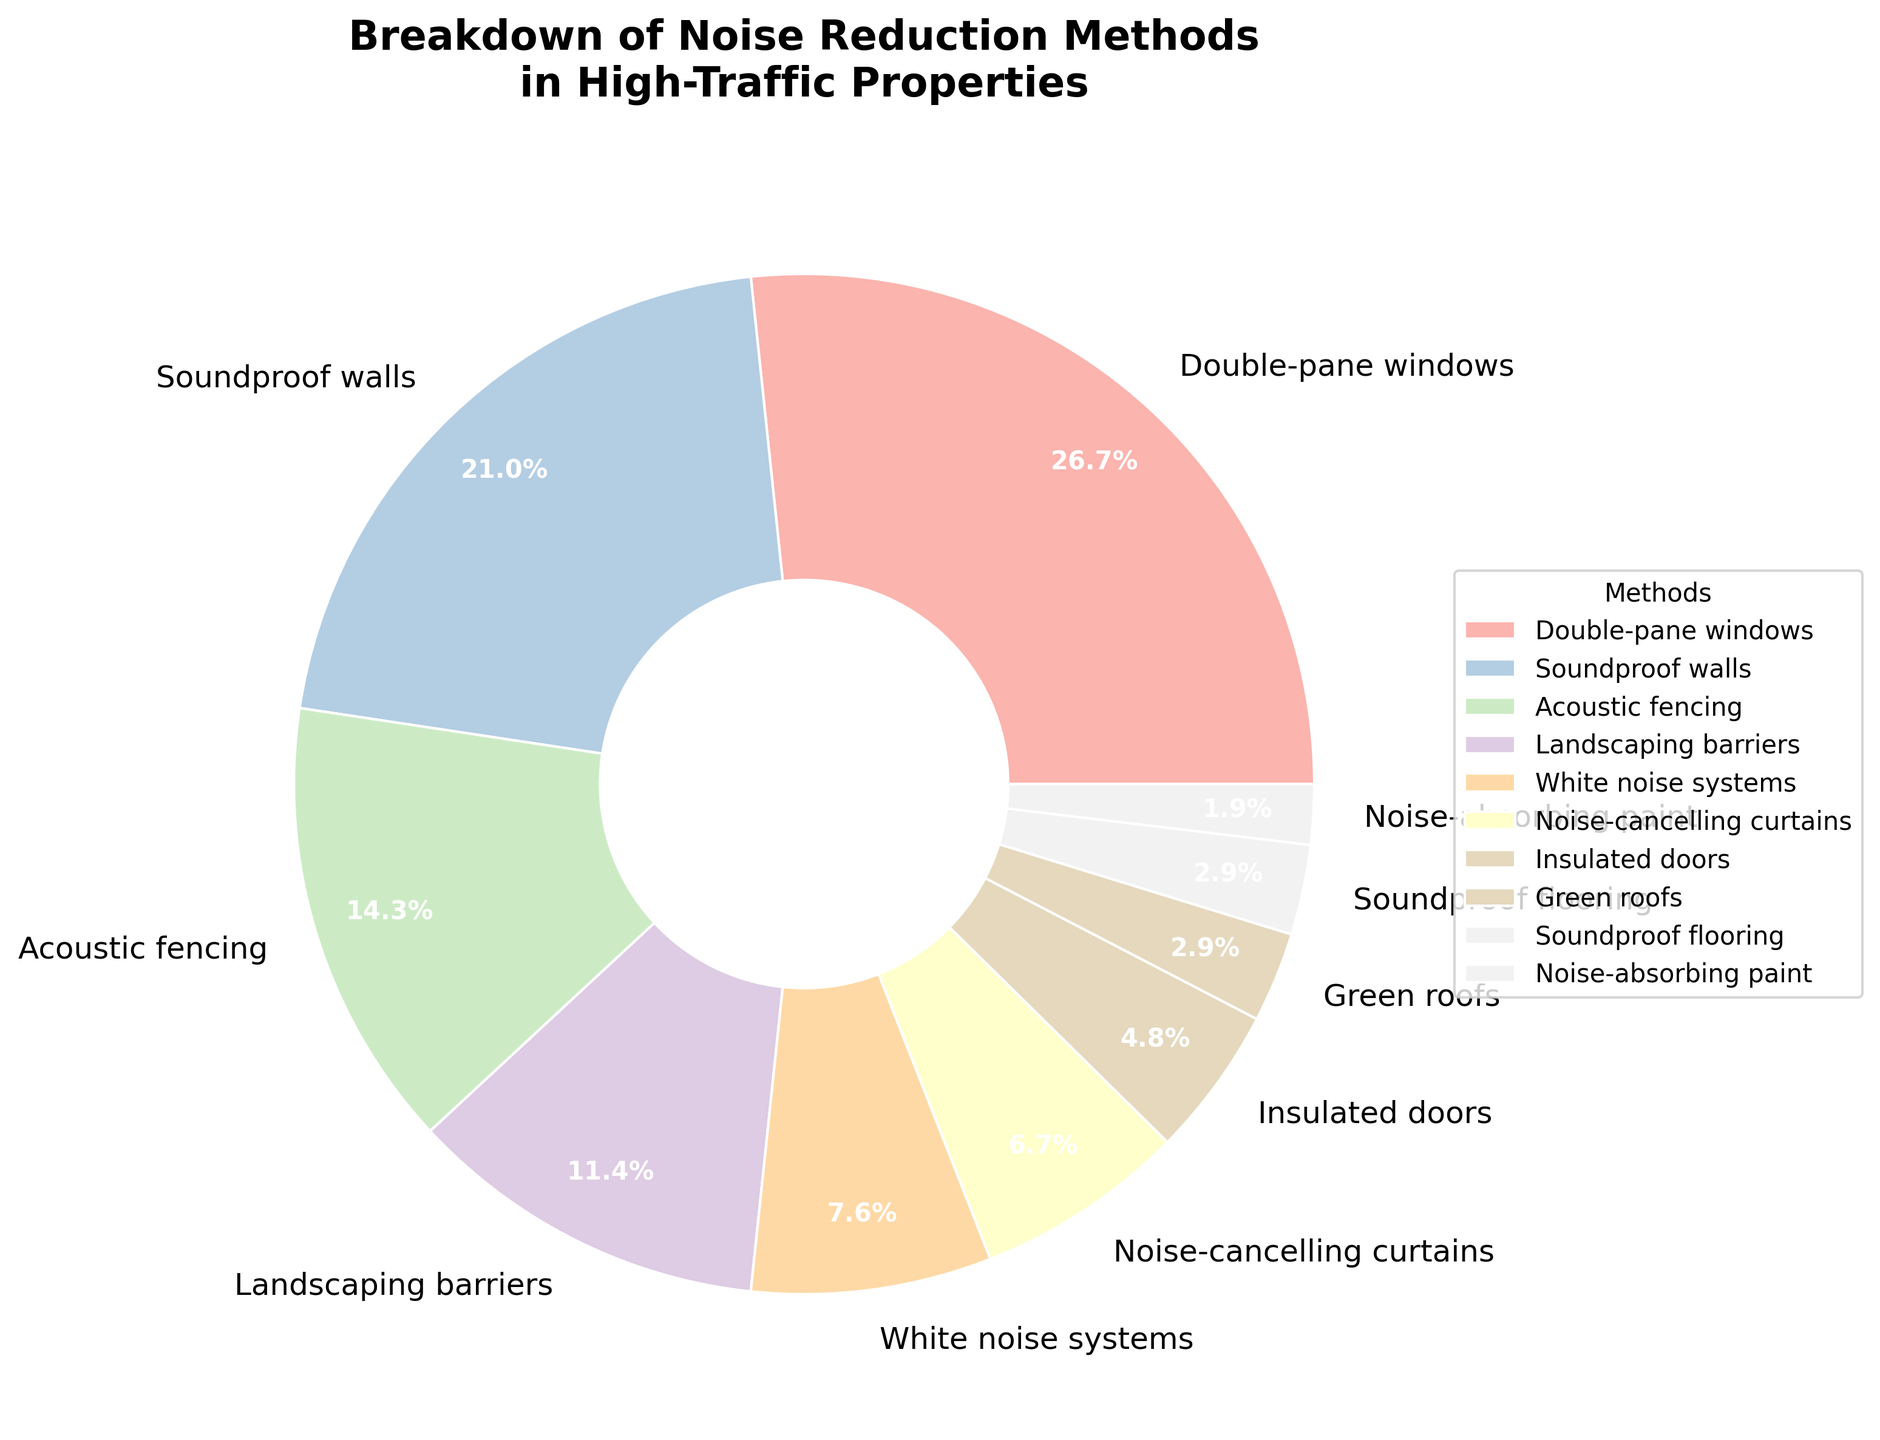What is the most common noise reduction method used in high-traffic properties? The most common noise reduction method is the one with the highest percentage in the pie chart. Double-pane windows have the largest section in the pie chart at 28%.
Answer: Double-pane windows Which noise reduction method is the least common? The least common method is the one with the smallest percentage in the pie chart. Noise-absorbing paint has the smallest section at 2%.
Answer: Noise-absorbing paint How much more popular are double-pane windows compared to soundproof walls? To find how much more popular double-pane windows are, subtract the percentage of soundproof walls from the percentage of double-pane windows: 28% - 22% = 6%.
Answer: 6% What percentage of noise reduction methods used involve modifying the structure of the property? (Consider double-pane windows, soundproof walls, and insulated doors) Sum the percentages of double-pane windows, soundproof walls, and insulated doors: 28% + 22% + 5% = 55%.
Answer: 55% Which noise reduction methods each constitute less than 5% of the total? Identify the methods with percentages less than 5% in the pie chart. Green roofs, soundproof flooring, and noise-absorbing paint each have less than 5%.
Answer: Green roofs, Soundproof flooring, Noise-absorbing paint Are landscaping barriers more or less common than white noise systems? Compare the percentages for landscaping barriers and white noise systems. Landscaping barriers are 12%, white noise systems are 8%, so landscaping barriers are more common.
Answer: More common What is the combined percentage of acoustic fencing and noise-cancelling curtains? Sum the percentages of acoustic fencing and noise-cancelling curtains: 15% + 7% = 22%.
Answer: 22% How many noise reduction methods constitute at least 10% of the total? Count the segments in the pie chart with percentages of 10% or more. There are four methods (double-pane windows, soundproof walls, acoustic fencing, and landscaping barriers).
Answer: Four What proportion of the total noise reduction methods do green roofs and noise-absorbing paint represent together? Sum the percentages of green roofs and noise-absorbing paint: 3% + 2% = 5%.
Answer: 5% Is the percentage of insulated doors greater than or equal to half the percentage of double-pane windows? Calculate half the percentage of double-pane windows (28% / 2 = 14%) and compare it to the percentage of insulated doors (5%). Insulated doors are less than half the percentage of double-pane windows.
Answer: Less 